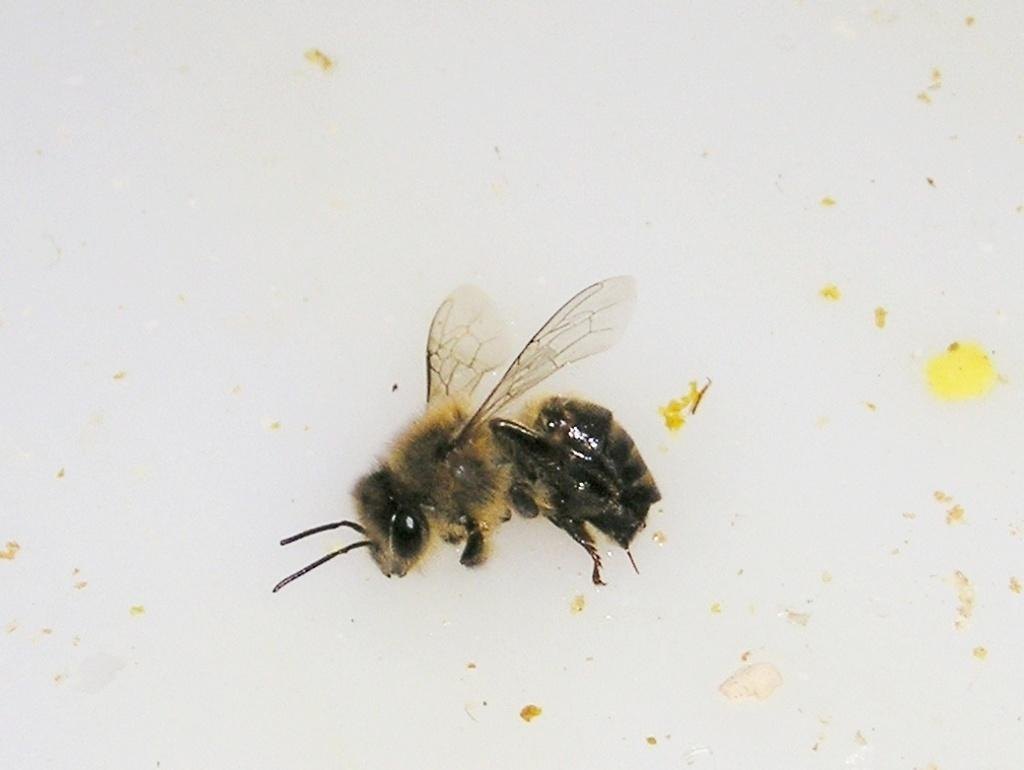What type of creature can be seen in the image? There is an insect in the image. What type of destruction is the insect causing in the image? There is no indication of destruction in the image; it simply features an insect. In which direction is the insect moving in the image? There is no indication of the insect's movement in the image. Is there a cable visible in the image? There is no mention of a cable in the provided facts, so it cannot be determined if one is present in the image. 